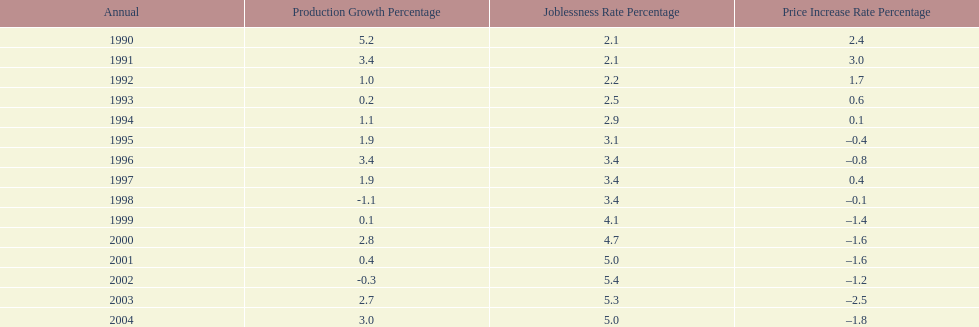What year had the highest unemployment rate? 2002. 